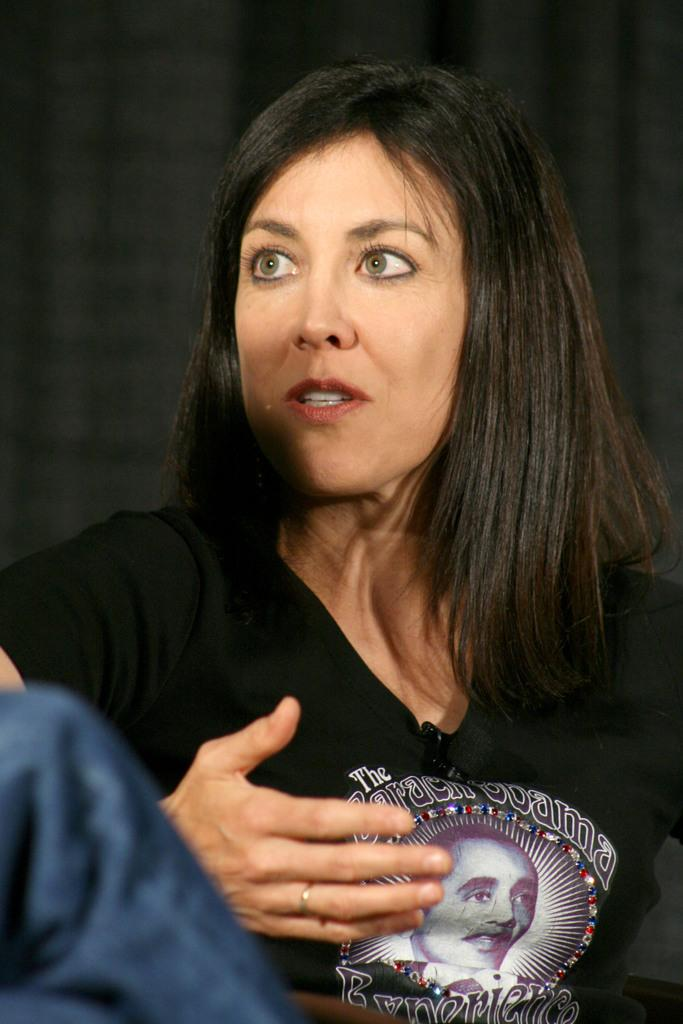What is the woman in the image doing? The woman is seated in the image. What is the woman wearing in the image? The woman is wearing a black t-shirt in the image. What is on the woman's back in the image? The woman has a black cloth on her back in the image. Who else is present in the image? There is a human seated on the side of the woman in the image. What type of verse can be heard being recited by the woman in the image? There is no indication in the image that the woman is reciting any verse, so it cannot be determined from the picture. 